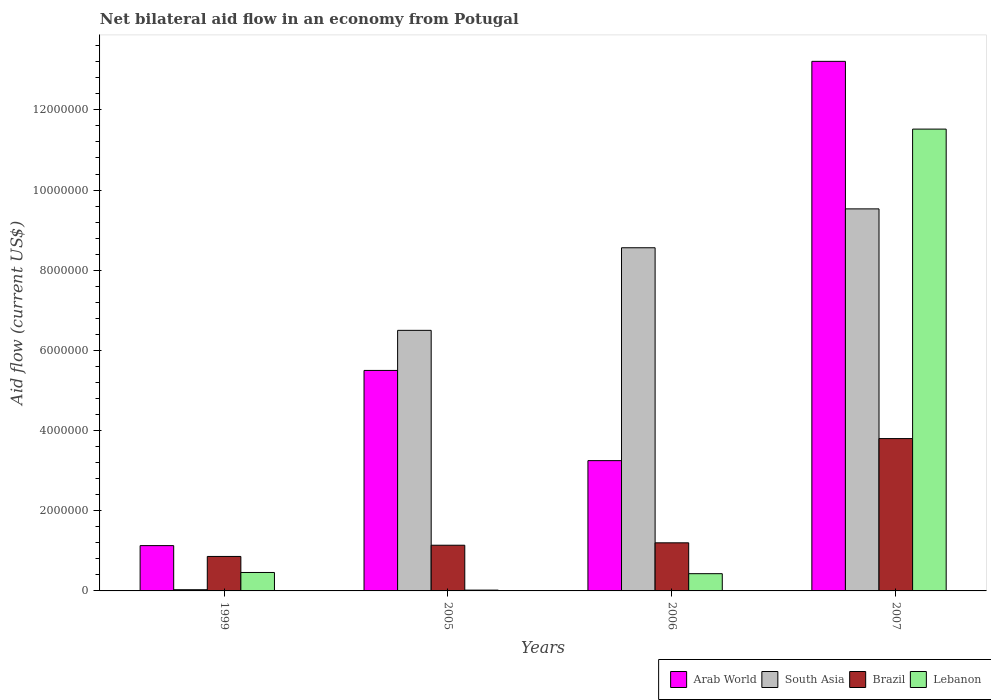Are the number of bars on each tick of the X-axis equal?
Provide a short and direct response. Yes. How many bars are there on the 3rd tick from the left?
Provide a short and direct response. 4. In how many cases, is the number of bars for a given year not equal to the number of legend labels?
Provide a succinct answer. 0. What is the net bilateral aid flow in Brazil in 2005?
Keep it short and to the point. 1.14e+06. Across all years, what is the maximum net bilateral aid flow in Arab World?
Ensure brevity in your answer.  1.32e+07. Across all years, what is the minimum net bilateral aid flow in Lebanon?
Give a very brief answer. 2.00e+04. In which year was the net bilateral aid flow in South Asia maximum?
Offer a very short reply. 2007. What is the total net bilateral aid flow in Arab World in the graph?
Offer a terse response. 2.31e+07. What is the difference between the net bilateral aid flow in Lebanon in 1999 and that in 2007?
Your response must be concise. -1.11e+07. What is the difference between the net bilateral aid flow in Arab World in 2007 and the net bilateral aid flow in Brazil in 2006?
Your answer should be compact. 1.20e+07. What is the average net bilateral aid flow in South Asia per year?
Provide a succinct answer. 6.16e+06. In the year 2007, what is the difference between the net bilateral aid flow in South Asia and net bilateral aid flow in Lebanon?
Your response must be concise. -1.99e+06. In how many years, is the net bilateral aid flow in Brazil greater than 10000000 US$?
Provide a short and direct response. 0. What is the ratio of the net bilateral aid flow in South Asia in 1999 to that in 2007?
Offer a very short reply. 0. Is the difference between the net bilateral aid flow in South Asia in 2006 and 2007 greater than the difference between the net bilateral aid flow in Lebanon in 2006 and 2007?
Make the answer very short. Yes. What is the difference between the highest and the second highest net bilateral aid flow in Arab World?
Offer a very short reply. 7.71e+06. What is the difference between the highest and the lowest net bilateral aid flow in Brazil?
Provide a short and direct response. 2.94e+06. Is the sum of the net bilateral aid flow in Arab World in 2005 and 2006 greater than the maximum net bilateral aid flow in Brazil across all years?
Your answer should be compact. Yes. Is it the case that in every year, the sum of the net bilateral aid flow in Arab World and net bilateral aid flow in South Asia is greater than the sum of net bilateral aid flow in Brazil and net bilateral aid flow in Lebanon?
Offer a terse response. No. What does the 4th bar from the right in 2006 represents?
Your answer should be very brief. Arab World. How many bars are there?
Ensure brevity in your answer.  16. What is the difference between two consecutive major ticks on the Y-axis?
Offer a terse response. 2.00e+06. What is the title of the graph?
Make the answer very short. Net bilateral aid flow in an economy from Potugal. Does "Turks and Caicos Islands" appear as one of the legend labels in the graph?
Ensure brevity in your answer.  No. What is the label or title of the Y-axis?
Your response must be concise. Aid flow (current US$). What is the Aid flow (current US$) of Arab World in 1999?
Your answer should be compact. 1.13e+06. What is the Aid flow (current US$) of Brazil in 1999?
Your response must be concise. 8.60e+05. What is the Aid flow (current US$) of Lebanon in 1999?
Ensure brevity in your answer.  4.60e+05. What is the Aid flow (current US$) in Arab World in 2005?
Your answer should be very brief. 5.50e+06. What is the Aid flow (current US$) of South Asia in 2005?
Provide a short and direct response. 6.50e+06. What is the Aid flow (current US$) in Brazil in 2005?
Keep it short and to the point. 1.14e+06. What is the Aid flow (current US$) of Lebanon in 2005?
Provide a succinct answer. 2.00e+04. What is the Aid flow (current US$) of Arab World in 2006?
Provide a succinct answer. 3.25e+06. What is the Aid flow (current US$) of South Asia in 2006?
Ensure brevity in your answer.  8.56e+06. What is the Aid flow (current US$) of Brazil in 2006?
Offer a terse response. 1.20e+06. What is the Aid flow (current US$) of Lebanon in 2006?
Give a very brief answer. 4.30e+05. What is the Aid flow (current US$) in Arab World in 2007?
Your answer should be compact. 1.32e+07. What is the Aid flow (current US$) of South Asia in 2007?
Provide a short and direct response. 9.53e+06. What is the Aid flow (current US$) in Brazil in 2007?
Your answer should be compact. 3.80e+06. What is the Aid flow (current US$) of Lebanon in 2007?
Offer a terse response. 1.15e+07. Across all years, what is the maximum Aid flow (current US$) in Arab World?
Ensure brevity in your answer.  1.32e+07. Across all years, what is the maximum Aid flow (current US$) in South Asia?
Provide a succinct answer. 9.53e+06. Across all years, what is the maximum Aid flow (current US$) in Brazil?
Give a very brief answer. 3.80e+06. Across all years, what is the maximum Aid flow (current US$) in Lebanon?
Keep it short and to the point. 1.15e+07. Across all years, what is the minimum Aid flow (current US$) in Arab World?
Make the answer very short. 1.13e+06. Across all years, what is the minimum Aid flow (current US$) in Brazil?
Your response must be concise. 8.60e+05. Across all years, what is the minimum Aid flow (current US$) of Lebanon?
Your response must be concise. 2.00e+04. What is the total Aid flow (current US$) of Arab World in the graph?
Keep it short and to the point. 2.31e+07. What is the total Aid flow (current US$) in South Asia in the graph?
Provide a short and direct response. 2.46e+07. What is the total Aid flow (current US$) in Lebanon in the graph?
Provide a short and direct response. 1.24e+07. What is the difference between the Aid flow (current US$) of Arab World in 1999 and that in 2005?
Give a very brief answer. -4.37e+06. What is the difference between the Aid flow (current US$) in South Asia in 1999 and that in 2005?
Your answer should be compact. -6.47e+06. What is the difference between the Aid flow (current US$) in Brazil in 1999 and that in 2005?
Make the answer very short. -2.80e+05. What is the difference between the Aid flow (current US$) of Lebanon in 1999 and that in 2005?
Make the answer very short. 4.40e+05. What is the difference between the Aid flow (current US$) in Arab World in 1999 and that in 2006?
Make the answer very short. -2.12e+06. What is the difference between the Aid flow (current US$) of South Asia in 1999 and that in 2006?
Make the answer very short. -8.53e+06. What is the difference between the Aid flow (current US$) of Brazil in 1999 and that in 2006?
Offer a very short reply. -3.40e+05. What is the difference between the Aid flow (current US$) of Lebanon in 1999 and that in 2006?
Offer a terse response. 3.00e+04. What is the difference between the Aid flow (current US$) of Arab World in 1999 and that in 2007?
Provide a succinct answer. -1.21e+07. What is the difference between the Aid flow (current US$) of South Asia in 1999 and that in 2007?
Give a very brief answer. -9.50e+06. What is the difference between the Aid flow (current US$) of Brazil in 1999 and that in 2007?
Keep it short and to the point. -2.94e+06. What is the difference between the Aid flow (current US$) in Lebanon in 1999 and that in 2007?
Make the answer very short. -1.11e+07. What is the difference between the Aid flow (current US$) of Arab World in 2005 and that in 2006?
Your response must be concise. 2.25e+06. What is the difference between the Aid flow (current US$) in South Asia in 2005 and that in 2006?
Provide a succinct answer. -2.06e+06. What is the difference between the Aid flow (current US$) of Lebanon in 2005 and that in 2006?
Ensure brevity in your answer.  -4.10e+05. What is the difference between the Aid flow (current US$) in Arab World in 2005 and that in 2007?
Offer a terse response. -7.71e+06. What is the difference between the Aid flow (current US$) of South Asia in 2005 and that in 2007?
Your response must be concise. -3.03e+06. What is the difference between the Aid flow (current US$) of Brazil in 2005 and that in 2007?
Offer a very short reply. -2.66e+06. What is the difference between the Aid flow (current US$) of Lebanon in 2005 and that in 2007?
Give a very brief answer. -1.15e+07. What is the difference between the Aid flow (current US$) in Arab World in 2006 and that in 2007?
Give a very brief answer. -9.96e+06. What is the difference between the Aid flow (current US$) of South Asia in 2006 and that in 2007?
Give a very brief answer. -9.70e+05. What is the difference between the Aid flow (current US$) in Brazil in 2006 and that in 2007?
Offer a very short reply. -2.60e+06. What is the difference between the Aid flow (current US$) in Lebanon in 2006 and that in 2007?
Ensure brevity in your answer.  -1.11e+07. What is the difference between the Aid flow (current US$) of Arab World in 1999 and the Aid flow (current US$) of South Asia in 2005?
Your response must be concise. -5.37e+06. What is the difference between the Aid flow (current US$) in Arab World in 1999 and the Aid flow (current US$) in Lebanon in 2005?
Offer a terse response. 1.11e+06. What is the difference between the Aid flow (current US$) of South Asia in 1999 and the Aid flow (current US$) of Brazil in 2005?
Your response must be concise. -1.11e+06. What is the difference between the Aid flow (current US$) of Brazil in 1999 and the Aid flow (current US$) of Lebanon in 2005?
Ensure brevity in your answer.  8.40e+05. What is the difference between the Aid flow (current US$) in Arab World in 1999 and the Aid flow (current US$) in South Asia in 2006?
Provide a succinct answer. -7.43e+06. What is the difference between the Aid flow (current US$) in Arab World in 1999 and the Aid flow (current US$) in Brazil in 2006?
Offer a very short reply. -7.00e+04. What is the difference between the Aid flow (current US$) in Arab World in 1999 and the Aid flow (current US$) in Lebanon in 2006?
Your answer should be compact. 7.00e+05. What is the difference between the Aid flow (current US$) in South Asia in 1999 and the Aid flow (current US$) in Brazil in 2006?
Offer a terse response. -1.17e+06. What is the difference between the Aid flow (current US$) in South Asia in 1999 and the Aid flow (current US$) in Lebanon in 2006?
Your response must be concise. -4.00e+05. What is the difference between the Aid flow (current US$) of Arab World in 1999 and the Aid flow (current US$) of South Asia in 2007?
Your response must be concise. -8.40e+06. What is the difference between the Aid flow (current US$) of Arab World in 1999 and the Aid flow (current US$) of Brazil in 2007?
Offer a terse response. -2.67e+06. What is the difference between the Aid flow (current US$) in Arab World in 1999 and the Aid flow (current US$) in Lebanon in 2007?
Ensure brevity in your answer.  -1.04e+07. What is the difference between the Aid flow (current US$) in South Asia in 1999 and the Aid flow (current US$) in Brazil in 2007?
Your answer should be compact. -3.77e+06. What is the difference between the Aid flow (current US$) of South Asia in 1999 and the Aid flow (current US$) of Lebanon in 2007?
Your response must be concise. -1.15e+07. What is the difference between the Aid flow (current US$) of Brazil in 1999 and the Aid flow (current US$) of Lebanon in 2007?
Your answer should be compact. -1.07e+07. What is the difference between the Aid flow (current US$) of Arab World in 2005 and the Aid flow (current US$) of South Asia in 2006?
Keep it short and to the point. -3.06e+06. What is the difference between the Aid flow (current US$) of Arab World in 2005 and the Aid flow (current US$) of Brazil in 2006?
Provide a succinct answer. 4.30e+06. What is the difference between the Aid flow (current US$) in Arab World in 2005 and the Aid flow (current US$) in Lebanon in 2006?
Ensure brevity in your answer.  5.07e+06. What is the difference between the Aid flow (current US$) in South Asia in 2005 and the Aid flow (current US$) in Brazil in 2006?
Give a very brief answer. 5.30e+06. What is the difference between the Aid flow (current US$) in South Asia in 2005 and the Aid flow (current US$) in Lebanon in 2006?
Offer a very short reply. 6.07e+06. What is the difference between the Aid flow (current US$) in Brazil in 2005 and the Aid flow (current US$) in Lebanon in 2006?
Your answer should be very brief. 7.10e+05. What is the difference between the Aid flow (current US$) in Arab World in 2005 and the Aid flow (current US$) in South Asia in 2007?
Offer a very short reply. -4.03e+06. What is the difference between the Aid flow (current US$) of Arab World in 2005 and the Aid flow (current US$) of Brazil in 2007?
Provide a short and direct response. 1.70e+06. What is the difference between the Aid flow (current US$) of Arab World in 2005 and the Aid flow (current US$) of Lebanon in 2007?
Provide a short and direct response. -6.02e+06. What is the difference between the Aid flow (current US$) of South Asia in 2005 and the Aid flow (current US$) of Brazil in 2007?
Offer a terse response. 2.70e+06. What is the difference between the Aid flow (current US$) of South Asia in 2005 and the Aid flow (current US$) of Lebanon in 2007?
Keep it short and to the point. -5.02e+06. What is the difference between the Aid flow (current US$) in Brazil in 2005 and the Aid flow (current US$) in Lebanon in 2007?
Provide a succinct answer. -1.04e+07. What is the difference between the Aid flow (current US$) in Arab World in 2006 and the Aid flow (current US$) in South Asia in 2007?
Give a very brief answer. -6.28e+06. What is the difference between the Aid flow (current US$) of Arab World in 2006 and the Aid flow (current US$) of Brazil in 2007?
Make the answer very short. -5.50e+05. What is the difference between the Aid flow (current US$) in Arab World in 2006 and the Aid flow (current US$) in Lebanon in 2007?
Your answer should be compact. -8.27e+06. What is the difference between the Aid flow (current US$) in South Asia in 2006 and the Aid flow (current US$) in Brazil in 2007?
Provide a short and direct response. 4.76e+06. What is the difference between the Aid flow (current US$) of South Asia in 2006 and the Aid flow (current US$) of Lebanon in 2007?
Offer a very short reply. -2.96e+06. What is the difference between the Aid flow (current US$) of Brazil in 2006 and the Aid flow (current US$) of Lebanon in 2007?
Offer a terse response. -1.03e+07. What is the average Aid flow (current US$) of Arab World per year?
Provide a short and direct response. 5.77e+06. What is the average Aid flow (current US$) of South Asia per year?
Provide a short and direct response. 6.16e+06. What is the average Aid flow (current US$) in Brazil per year?
Provide a succinct answer. 1.75e+06. What is the average Aid flow (current US$) in Lebanon per year?
Your answer should be very brief. 3.11e+06. In the year 1999, what is the difference between the Aid flow (current US$) in Arab World and Aid flow (current US$) in South Asia?
Provide a succinct answer. 1.10e+06. In the year 1999, what is the difference between the Aid flow (current US$) in Arab World and Aid flow (current US$) in Lebanon?
Make the answer very short. 6.70e+05. In the year 1999, what is the difference between the Aid flow (current US$) in South Asia and Aid flow (current US$) in Brazil?
Provide a succinct answer. -8.30e+05. In the year 1999, what is the difference between the Aid flow (current US$) in South Asia and Aid flow (current US$) in Lebanon?
Give a very brief answer. -4.30e+05. In the year 1999, what is the difference between the Aid flow (current US$) in Brazil and Aid flow (current US$) in Lebanon?
Offer a terse response. 4.00e+05. In the year 2005, what is the difference between the Aid flow (current US$) in Arab World and Aid flow (current US$) in South Asia?
Offer a very short reply. -1.00e+06. In the year 2005, what is the difference between the Aid flow (current US$) in Arab World and Aid flow (current US$) in Brazil?
Your answer should be compact. 4.36e+06. In the year 2005, what is the difference between the Aid flow (current US$) of Arab World and Aid flow (current US$) of Lebanon?
Your response must be concise. 5.48e+06. In the year 2005, what is the difference between the Aid flow (current US$) of South Asia and Aid flow (current US$) of Brazil?
Make the answer very short. 5.36e+06. In the year 2005, what is the difference between the Aid flow (current US$) in South Asia and Aid flow (current US$) in Lebanon?
Provide a succinct answer. 6.48e+06. In the year 2005, what is the difference between the Aid flow (current US$) in Brazil and Aid flow (current US$) in Lebanon?
Your response must be concise. 1.12e+06. In the year 2006, what is the difference between the Aid flow (current US$) of Arab World and Aid flow (current US$) of South Asia?
Your answer should be compact. -5.31e+06. In the year 2006, what is the difference between the Aid flow (current US$) in Arab World and Aid flow (current US$) in Brazil?
Provide a succinct answer. 2.05e+06. In the year 2006, what is the difference between the Aid flow (current US$) of Arab World and Aid flow (current US$) of Lebanon?
Make the answer very short. 2.82e+06. In the year 2006, what is the difference between the Aid flow (current US$) of South Asia and Aid flow (current US$) of Brazil?
Keep it short and to the point. 7.36e+06. In the year 2006, what is the difference between the Aid flow (current US$) of South Asia and Aid flow (current US$) of Lebanon?
Your answer should be compact. 8.13e+06. In the year 2006, what is the difference between the Aid flow (current US$) of Brazil and Aid flow (current US$) of Lebanon?
Offer a very short reply. 7.70e+05. In the year 2007, what is the difference between the Aid flow (current US$) of Arab World and Aid flow (current US$) of South Asia?
Offer a very short reply. 3.68e+06. In the year 2007, what is the difference between the Aid flow (current US$) of Arab World and Aid flow (current US$) of Brazil?
Ensure brevity in your answer.  9.41e+06. In the year 2007, what is the difference between the Aid flow (current US$) in Arab World and Aid flow (current US$) in Lebanon?
Your response must be concise. 1.69e+06. In the year 2007, what is the difference between the Aid flow (current US$) in South Asia and Aid flow (current US$) in Brazil?
Provide a succinct answer. 5.73e+06. In the year 2007, what is the difference between the Aid flow (current US$) in South Asia and Aid flow (current US$) in Lebanon?
Offer a terse response. -1.99e+06. In the year 2007, what is the difference between the Aid flow (current US$) in Brazil and Aid flow (current US$) in Lebanon?
Give a very brief answer. -7.72e+06. What is the ratio of the Aid flow (current US$) in Arab World in 1999 to that in 2005?
Ensure brevity in your answer.  0.21. What is the ratio of the Aid flow (current US$) of South Asia in 1999 to that in 2005?
Provide a succinct answer. 0. What is the ratio of the Aid flow (current US$) in Brazil in 1999 to that in 2005?
Your response must be concise. 0.75. What is the ratio of the Aid flow (current US$) in Arab World in 1999 to that in 2006?
Make the answer very short. 0.35. What is the ratio of the Aid flow (current US$) of South Asia in 1999 to that in 2006?
Offer a terse response. 0. What is the ratio of the Aid flow (current US$) of Brazil in 1999 to that in 2006?
Keep it short and to the point. 0.72. What is the ratio of the Aid flow (current US$) in Lebanon in 1999 to that in 2006?
Keep it short and to the point. 1.07. What is the ratio of the Aid flow (current US$) in Arab World in 1999 to that in 2007?
Give a very brief answer. 0.09. What is the ratio of the Aid flow (current US$) of South Asia in 1999 to that in 2007?
Offer a very short reply. 0. What is the ratio of the Aid flow (current US$) in Brazil in 1999 to that in 2007?
Give a very brief answer. 0.23. What is the ratio of the Aid flow (current US$) in Lebanon in 1999 to that in 2007?
Your response must be concise. 0.04. What is the ratio of the Aid flow (current US$) in Arab World in 2005 to that in 2006?
Keep it short and to the point. 1.69. What is the ratio of the Aid flow (current US$) of South Asia in 2005 to that in 2006?
Provide a short and direct response. 0.76. What is the ratio of the Aid flow (current US$) of Brazil in 2005 to that in 2006?
Your answer should be compact. 0.95. What is the ratio of the Aid flow (current US$) of Lebanon in 2005 to that in 2006?
Offer a very short reply. 0.05. What is the ratio of the Aid flow (current US$) in Arab World in 2005 to that in 2007?
Give a very brief answer. 0.42. What is the ratio of the Aid flow (current US$) in South Asia in 2005 to that in 2007?
Provide a short and direct response. 0.68. What is the ratio of the Aid flow (current US$) in Brazil in 2005 to that in 2007?
Provide a short and direct response. 0.3. What is the ratio of the Aid flow (current US$) of Lebanon in 2005 to that in 2007?
Your response must be concise. 0. What is the ratio of the Aid flow (current US$) in Arab World in 2006 to that in 2007?
Your response must be concise. 0.25. What is the ratio of the Aid flow (current US$) of South Asia in 2006 to that in 2007?
Offer a terse response. 0.9. What is the ratio of the Aid flow (current US$) in Brazil in 2006 to that in 2007?
Provide a short and direct response. 0.32. What is the ratio of the Aid flow (current US$) in Lebanon in 2006 to that in 2007?
Provide a short and direct response. 0.04. What is the difference between the highest and the second highest Aid flow (current US$) of Arab World?
Ensure brevity in your answer.  7.71e+06. What is the difference between the highest and the second highest Aid flow (current US$) in South Asia?
Your response must be concise. 9.70e+05. What is the difference between the highest and the second highest Aid flow (current US$) of Brazil?
Offer a terse response. 2.60e+06. What is the difference between the highest and the second highest Aid flow (current US$) of Lebanon?
Keep it short and to the point. 1.11e+07. What is the difference between the highest and the lowest Aid flow (current US$) of Arab World?
Offer a terse response. 1.21e+07. What is the difference between the highest and the lowest Aid flow (current US$) in South Asia?
Ensure brevity in your answer.  9.50e+06. What is the difference between the highest and the lowest Aid flow (current US$) of Brazil?
Ensure brevity in your answer.  2.94e+06. What is the difference between the highest and the lowest Aid flow (current US$) of Lebanon?
Provide a short and direct response. 1.15e+07. 